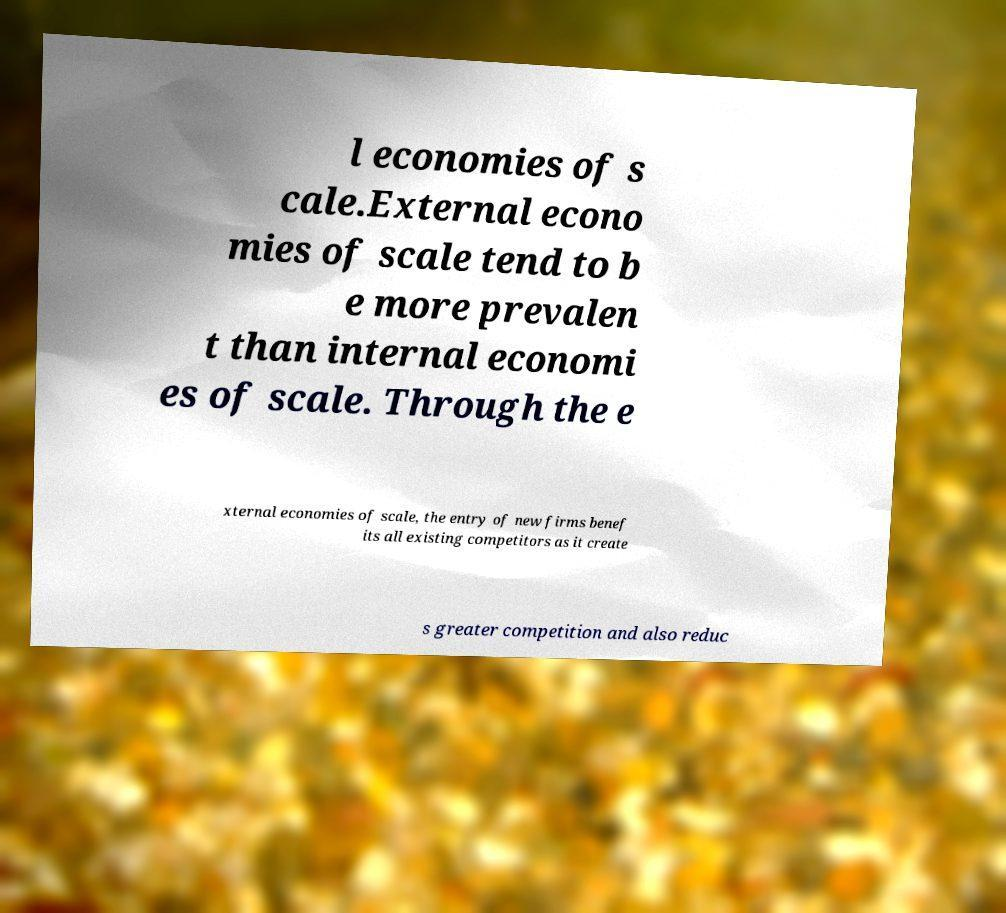Could you extract and type out the text from this image? l economies of s cale.External econo mies of scale tend to b e more prevalen t than internal economi es of scale. Through the e xternal economies of scale, the entry of new firms benef its all existing competitors as it create s greater competition and also reduc 